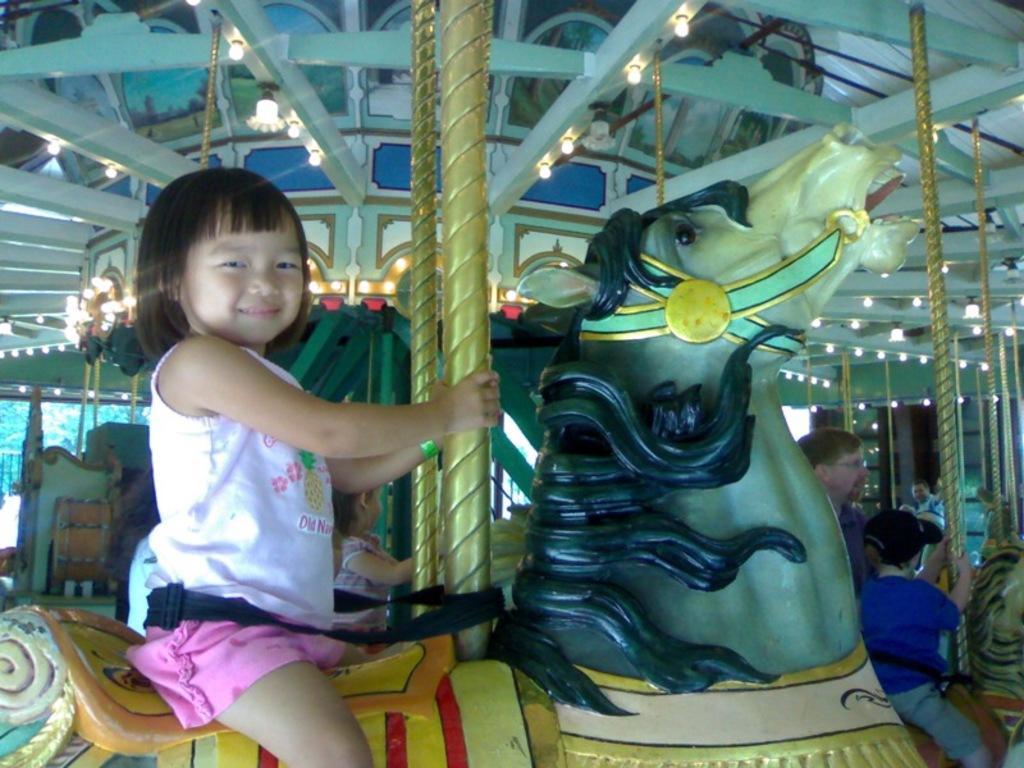How would you summarize this image in a sentence or two? In the image few children are riding carousel. 